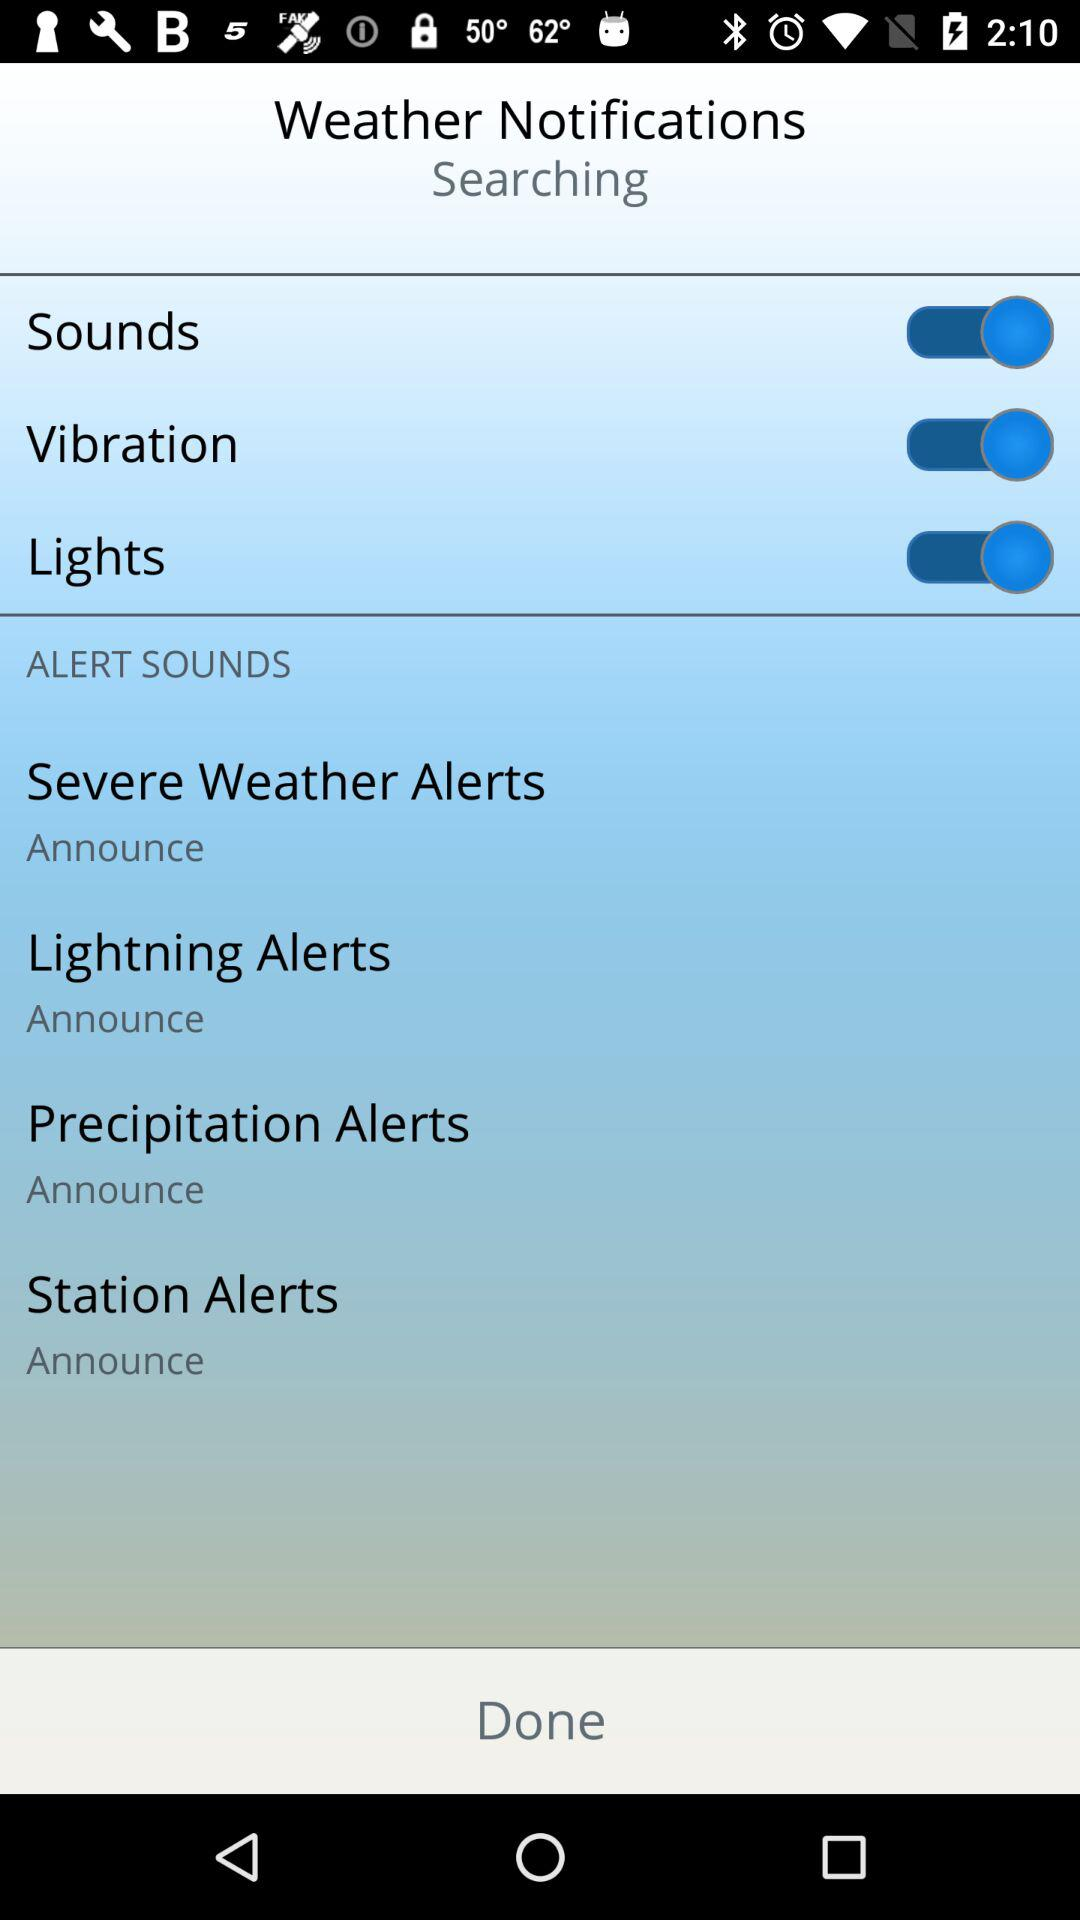What is the alert sound for "Severe Weather Alerts"? The alert sound for "Severe Weather Alerts" is "Announce". 